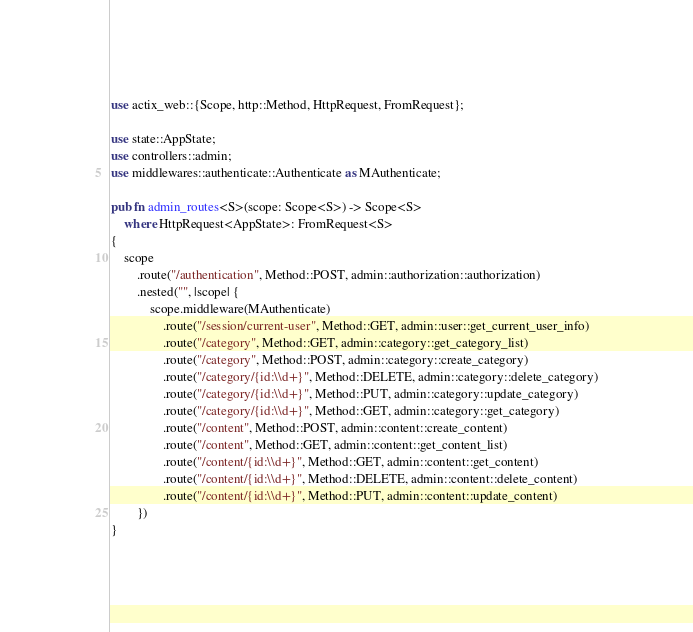<code> <loc_0><loc_0><loc_500><loc_500><_Rust_>use actix_web::{Scope, http::Method, HttpRequest, FromRequest};

use state::AppState;
use controllers::admin;
use middlewares::authenticate::Authenticate as MAuthenticate;

pub fn admin_routes<S>(scope: Scope<S>) -> Scope<S>
    where HttpRequest<AppState>: FromRequest<S>
{
    scope
        .route("/authentication", Method::POST, admin::authorization::authorization)
        .nested("", |scope| {
            scope.middleware(MAuthenticate)
                .route("/session/current-user", Method::GET, admin::user::get_current_user_info)
                .route("/category", Method::GET, admin::category::get_category_list)
                .route("/category", Method::POST, admin::category::create_category)
                .route("/category/{id:\\d+}", Method::DELETE, admin::category::delete_category)
                .route("/category/{id:\\d+}", Method::PUT, admin::category::update_category)
                .route("/category/{id:\\d+}", Method::GET, admin::category::get_category)
                .route("/content", Method::POST, admin::content::create_content)
                .route("/content", Method::GET, admin::content::get_content_list)
                .route("/content/{id:\\d+}", Method::GET, admin::content::get_content)
                .route("/content/{id:\\d+}", Method::DELETE, admin::content::delete_content)
                .route("/content/{id:\\d+}", Method::PUT, admin::content::update_content)
        })
}</code> 